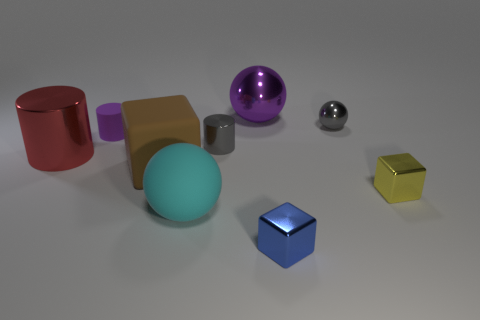There is a yellow metallic cube behind the thing that is in front of the cyan sphere; is there a metal thing that is in front of it?
Your response must be concise. Yes. How many cylinders are there?
Offer a very short reply. 3. What number of objects are either spheres behind the red object or big brown rubber blocks to the left of the yellow cube?
Give a very brief answer. 3. There is a purple object right of the purple rubber cylinder; is its size the same as the brown object?
Offer a very short reply. Yes. The yellow object that is the same shape as the brown matte thing is what size?
Ensure brevity in your answer.  Small. There is a block that is the same size as the matte ball; what is it made of?
Ensure brevity in your answer.  Rubber. There is a small gray thing that is the same shape as the big cyan thing; what material is it?
Keep it short and to the point. Metal. What number of other things are the same size as the purple metal object?
Provide a short and direct response. 3. What is the size of the metallic cylinder that is the same color as the tiny sphere?
Offer a very short reply. Small. How many small metal spheres have the same color as the tiny shiny cylinder?
Provide a succinct answer. 1. 